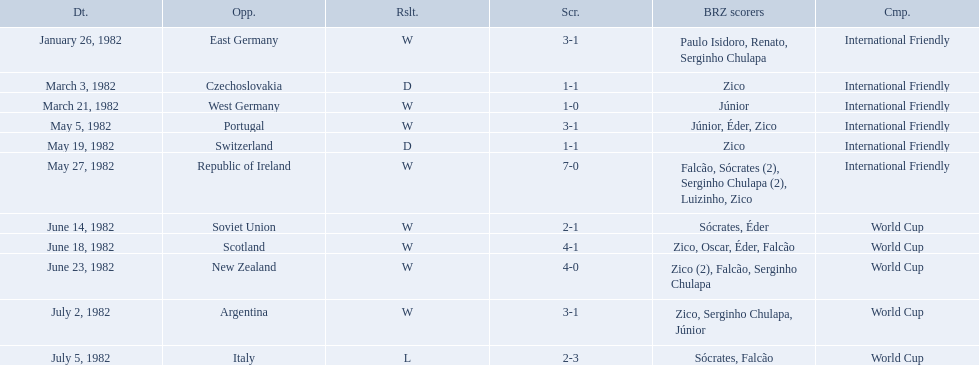What are all the dates of games in 1982 in brazilian football? January 26, 1982, March 3, 1982, March 21, 1982, May 5, 1982, May 19, 1982, May 27, 1982, June 14, 1982, June 18, 1982, June 23, 1982, July 2, 1982, July 5, 1982. Which of these dates is at the top of the chart? January 26, 1982. Who did brazil play against Soviet Union. Who scored the most goals? Portugal. 